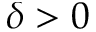Convert formula to latex. <formula><loc_0><loc_0><loc_500><loc_500>\delta > 0</formula> 